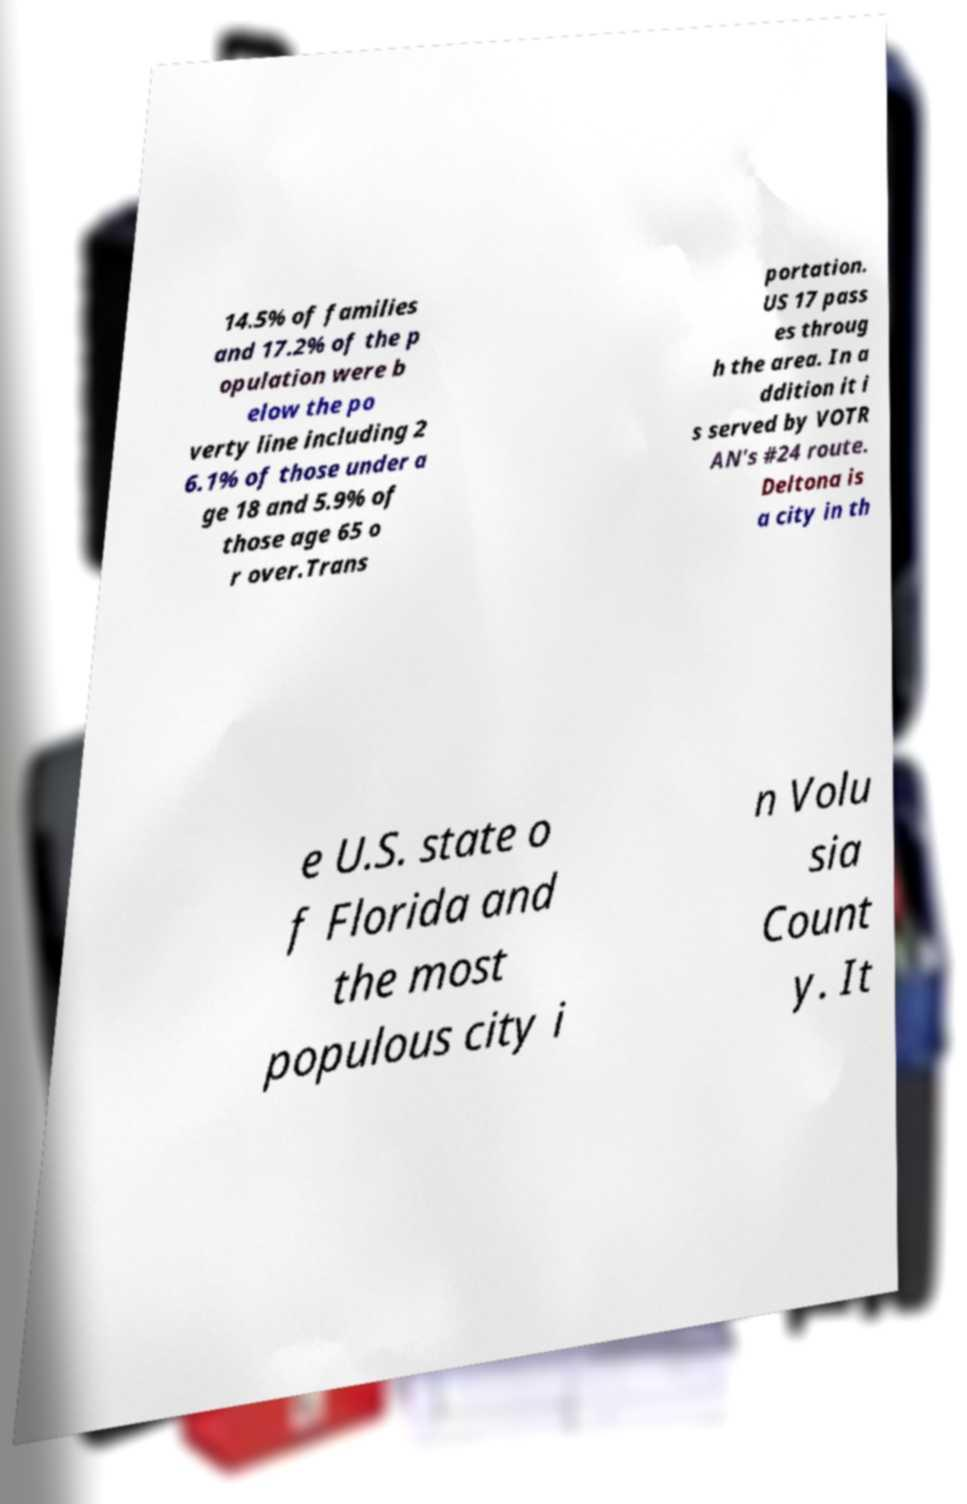Can you accurately transcribe the text from the provided image for me? 14.5% of families and 17.2% of the p opulation were b elow the po verty line including 2 6.1% of those under a ge 18 and 5.9% of those age 65 o r over.Trans portation. US 17 pass es throug h the area. In a ddition it i s served by VOTR AN's #24 route. Deltona is a city in th e U.S. state o f Florida and the most populous city i n Volu sia Count y. It 